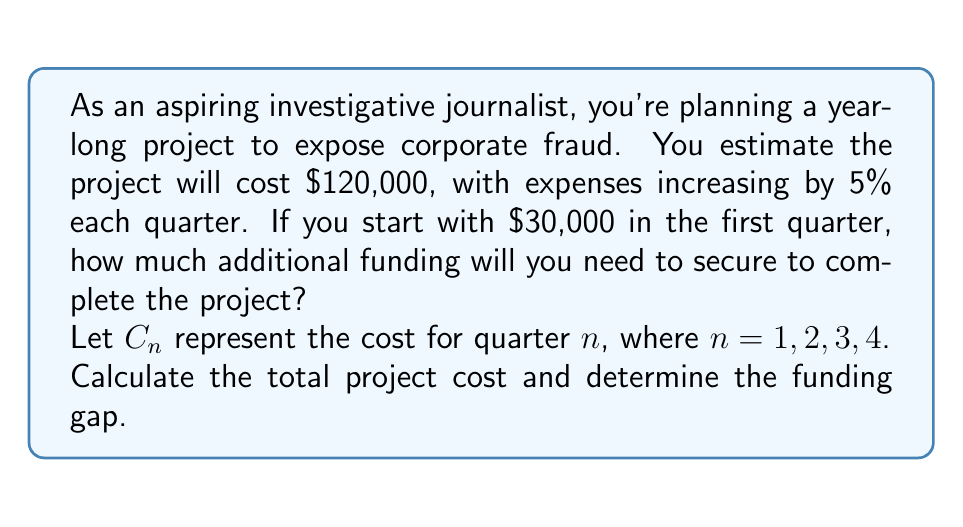Show me your answer to this math problem. Let's approach this step-by-step:

1) We know that $C_1 = \$30,000$ (given in the question)

2) For each subsequent quarter, the cost increases by 5%. We can represent this as:
   $C_n = C_1 \cdot (1.05)^{n-1}$ for $n = 1, 2, 3, 4$

3) Let's calculate the cost for each quarter:
   $C_1 = \$30,000$
   $C_2 = \$30,000 \cdot (1.05)^1 = \$31,500$
   $C_3 = \$30,000 \cdot (1.05)^2 = \$33,075$
   $C_4 = \$30,000 \cdot (1.05)^3 = \$34,728.75$

4) The total project cost is the sum of these four quarters:
   $\text{Total Cost} = C_1 + C_2 + C_3 + C_4$
   $\text{Total Cost} = \$30,000 + \$31,500 + \$33,075 + \$34,728.75$
   $\text{Total Cost} = \$129,303.75$

5) The funding gap is the difference between the total cost and the estimated cost:
   $\text{Funding Gap} = \text{Total Cost} - \text{Estimated Cost}$
   $\text{Funding Gap} = \$129,303.75 - \$120,000 = \$9,303.75$

Therefore, you will need to secure an additional $9,303.75 in funding to complete the project.
Answer: $9,303.75 